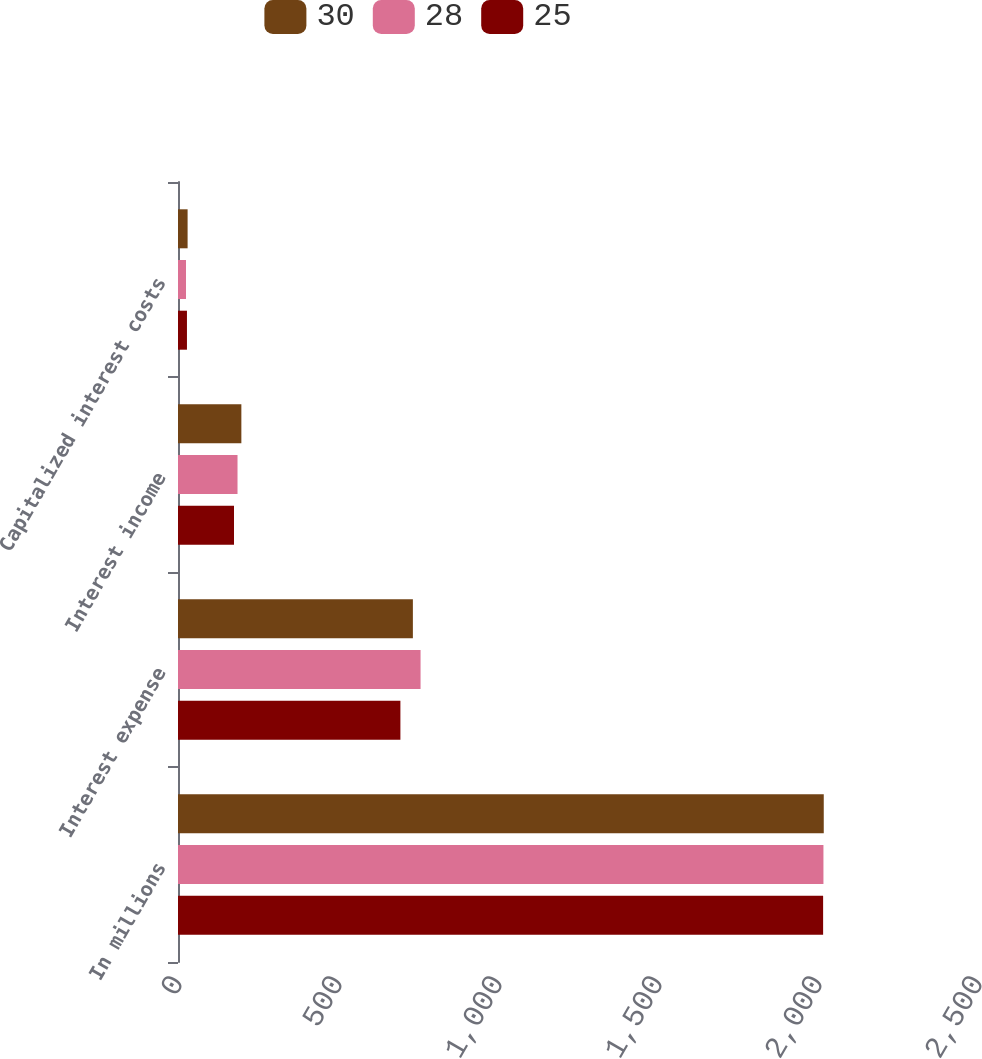<chart> <loc_0><loc_0><loc_500><loc_500><stacked_bar_chart><ecel><fcel>In millions<fcel>Interest expense<fcel>Interest income<fcel>Capitalized interest costs<nl><fcel>30<fcel>2018<fcel>734<fcel>198<fcel>30<nl><fcel>28<fcel>2017<fcel>758<fcel>186<fcel>25<nl><fcel>25<fcel>2016<fcel>695<fcel>175<fcel>28<nl></chart> 